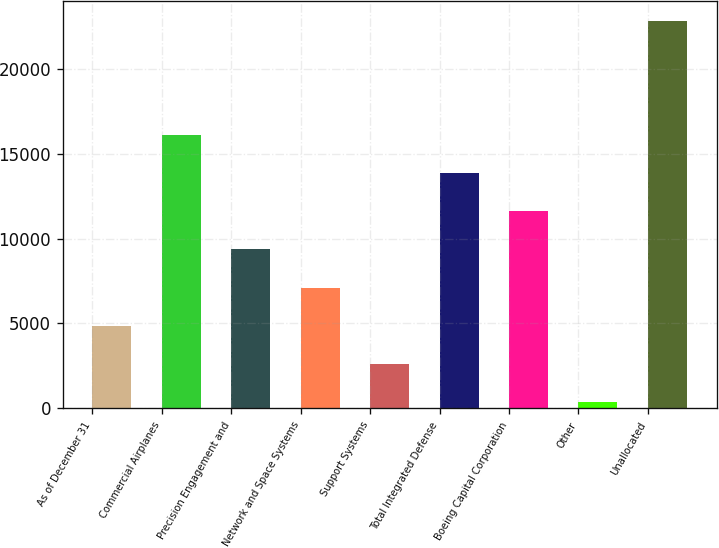Convert chart. <chart><loc_0><loc_0><loc_500><loc_500><bar_chart><fcel>As of December 31<fcel>Commercial Airplanes<fcel>Precision Engagement and<fcel>Network and Space Systems<fcel>Support Systems<fcel>Total Integrated Defense<fcel>Boeing Capital Corporation<fcel>Other<fcel>Unallocated<nl><fcel>4872.2<fcel>16090.2<fcel>9359.4<fcel>7115.8<fcel>2628.6<fcel>13846.6<fcel>11603<fcel>385<fcel>22821<nl></chart> 